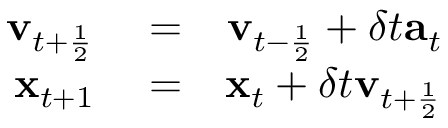Convert formula to latex. <formula><loc_0><loc_0><loc_500><loc_500>\begin{array} { r l r } { v _ { t + \frac { 1 } { 2 } } } & = } & { v _ { t - \frac { 1 } { 2 } } + \delta t a _ { t } } \\ { x _ { t + 1 } } & = } & { x _ { t } + \delta t v _ { t + \frac { 1 } { 2 } } } \end{array}</formula> 